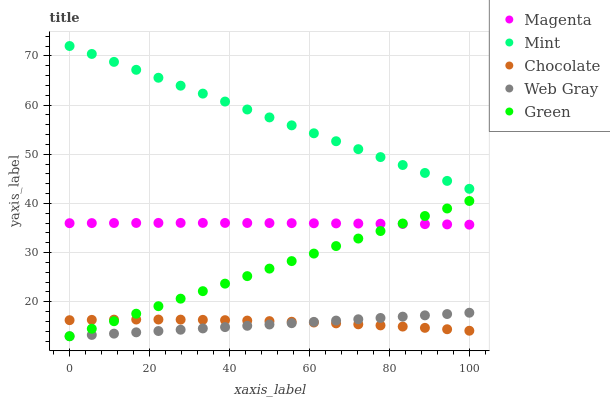Does Web Gray have the minimum area under the curve?
Answer yes or no. Yes. Does Mint have the maximum area under the curve?
Answer yes or no. Yes. Does Magenta have the minimum area under the curve?
Answer yes or no. No. Does Magenta have the maximum area under the curve?
Answer yes or no. No. Is Green the smoothest?
Answer yes or no. Yes. Is Chocolate the roughest?
Answer yes or no. Yes. Is Magenta the smoothest?
Answer yes or no. No. Is Magenta the roughest?
Answer yes or no. No. Does Green have the lowest value?
Answer yes or no. Yes. Does Magenta have the lowest value?
Answer yes or no. No. Does Mint have the highest value?
Answer yes or no. Yes. Does Magenta have the highest value?
Answer yes or no. No. Is Green less than Mint?
Answer yes or no. Yes. Is Magenta greater than Chocolate?
Answer yes or no. Yes. Does Chocolate intersect Web Gray?
Answer yes or no. Yes. Is Chocolate less than Web Gray?
Answer yes or no. No. Is Chocolate greater than Web Gray?
Answer yes or no. No. Does Green intersect Mint?
Answer yes or no. No. 